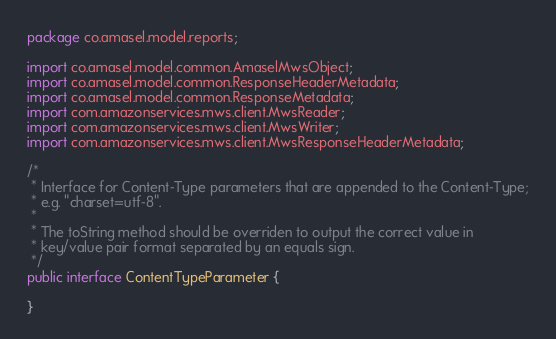Convert code to text. <code><loc_0><loc_0><loc_500><loc_500><_Java_>package co.amasel.model.reports;

import co.amasel.model.common.AmaselMwsObject;
import co.amasel.model.common.ResponseHeaderMetadata;
import co.amasel.model.common.ResponseMetadata;
import com.amazonservices.mws.client.MwsReader;
import com.amazonservices.mws.client.MwsWriter;
import com.amazonservices.mws.client.MwsResponseHeaderMetadata;

/*
 * Interface for Content-Type parameters that are appended to the Content-Type;
 * e.g. "charset=utf-8".
 * 
 * The toString method should be overriden to output the correct value in
 * key/value pair format separated by an equals sign.
 */
public interface ContentTypeParameter {

}
</code> 